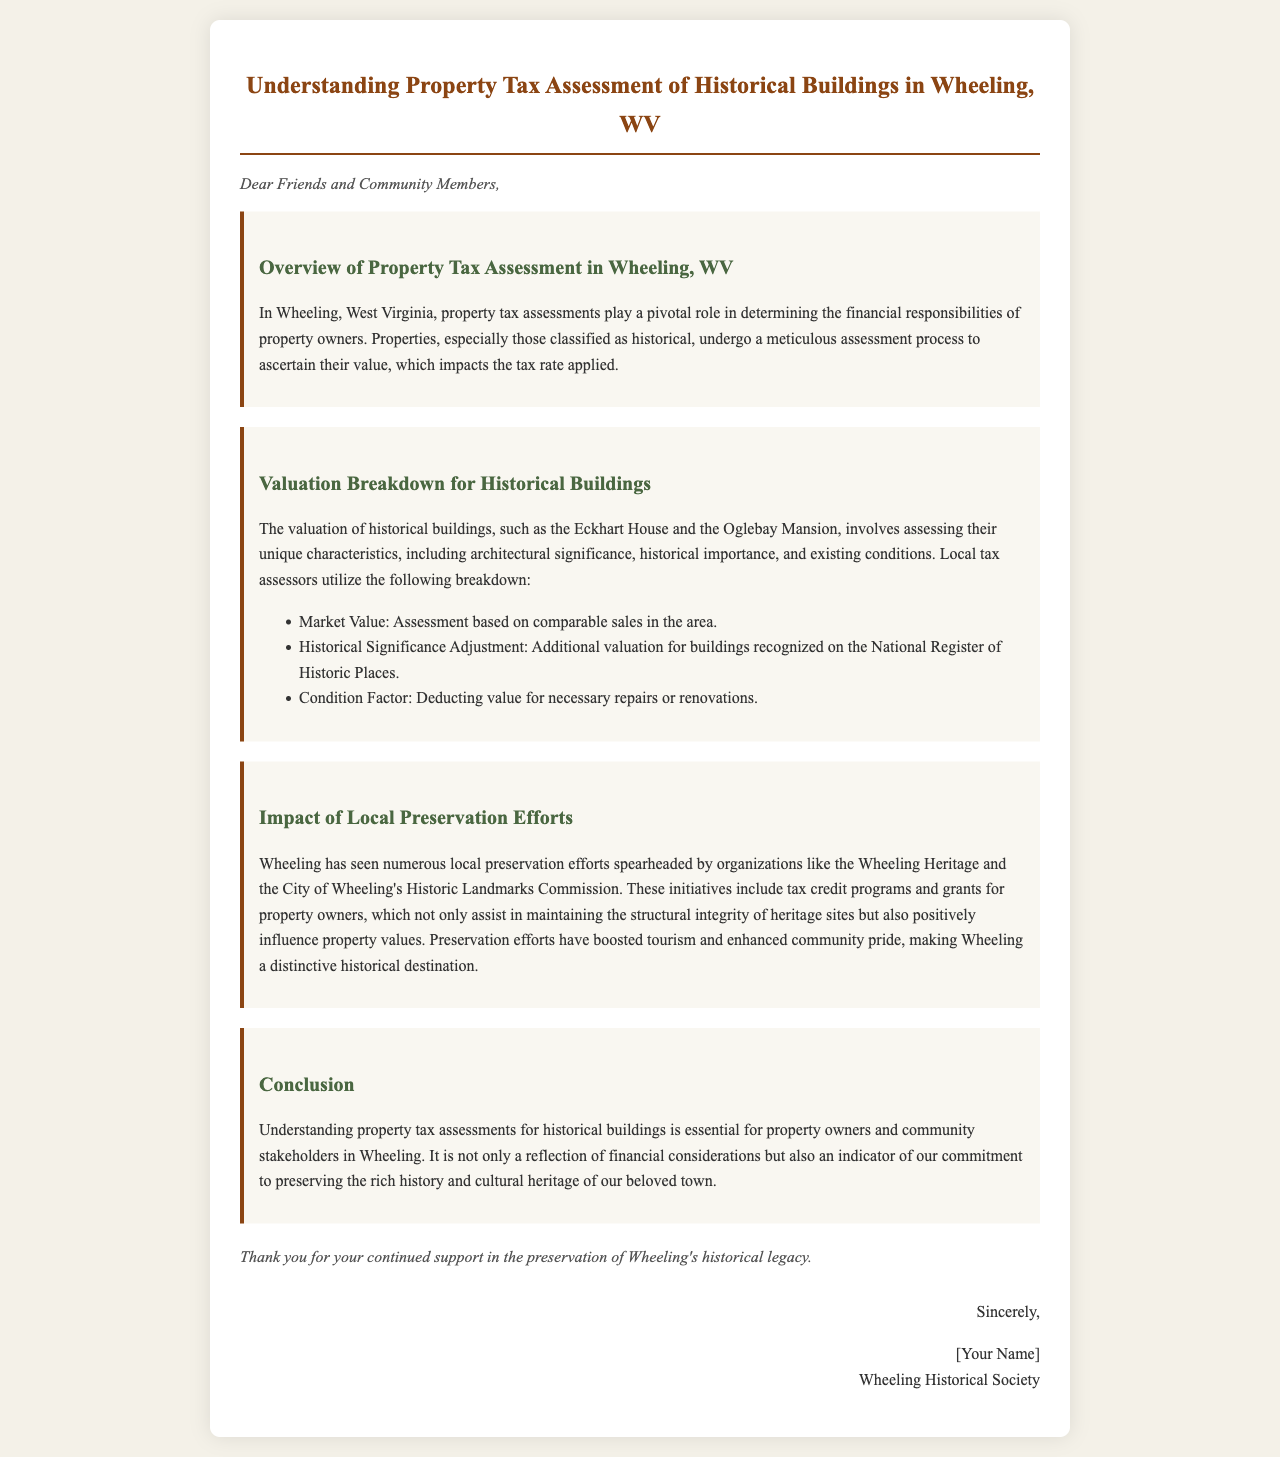What is the title of the document? The title is included in the header of the document.
Answer: Understanding Property Tax Assessment of Historical Buildings in Wheeling, WV What are two historical buildings mentioned in the valuation breakdown? The document lists specific historical buildings as examples in the valuation breakdown.
Answer: Eckhart House and Oglebay Mansion Which organizations are mentioned as part of local preservation efforts? The document specifically names organizations involved in preservation efforts in Wheeling.
Answer: Wheeling Heritage and City of Wheeling's Historic Landmarks Commission What is one component of the valuation breakdown for historical buildings? The document lists multiple components of the valuation breakdown.
Answer: Market Value According to the conclusion, what is essential for property owners and community stakeholders? The document states essential information related to property tax assessments.
Answer: Understanding property tax assessments for historical buildings What impact do preservation efforts have on property values according to the document? The impact of preservation efforts is discussed in terms of influence on the community.
Answer: Positively influence What is mentioned about tourism in relation to preservation efforts? The document mentions the effect of preservation efforts on tourism.
Answer: Boosted tourism What style is the body text of this document? The style of the text is noted in the document's CSS for formatting.
Answer: Bookman Old Style 